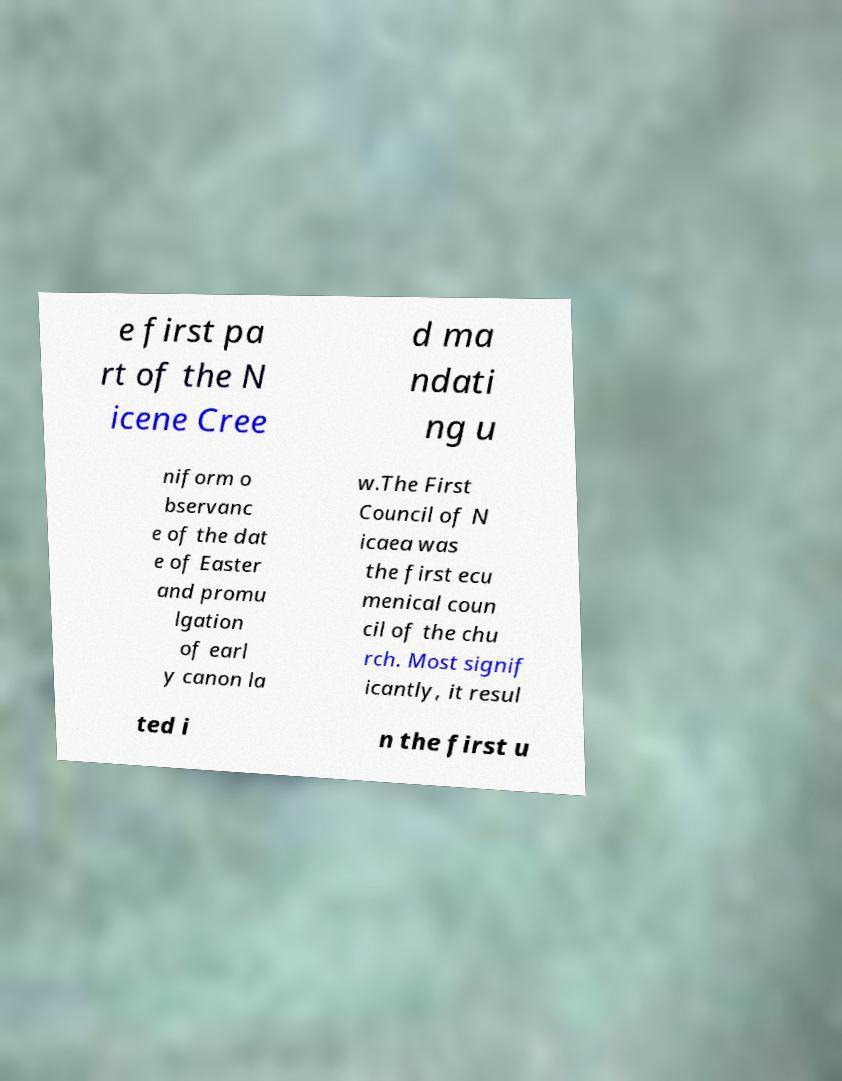Please read and relay the text visible in this image. What does it say? e first pa rt of the N icene Cree d ma ndati ng u niform o bservanc e of the dat e of Easter and promu lgation of earl y canon la w.The First Council of N icaea was the first ecu menical coun cil of the chu rch. Most signif icantly, it resul ted i n the first u 